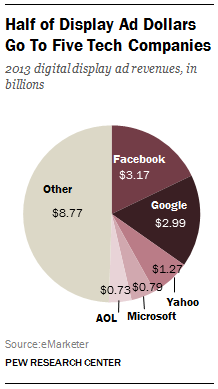Mention a couple of crucial points in this snapshot. Facebook and Google's ad revenue do not differ by more than $1 billion. The share of Facebook in the given graph is 3.17%. 